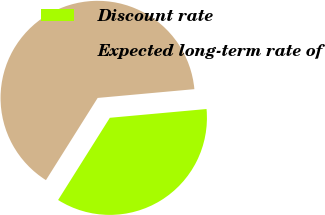<chart> <loc_0><loc_0><loc_500><loc_500><pie_chart><fcel>Discount rate<fcel>Expected long-term rate of<nl><fcel>35.38%<fcel>64.62%<nl></chart> 